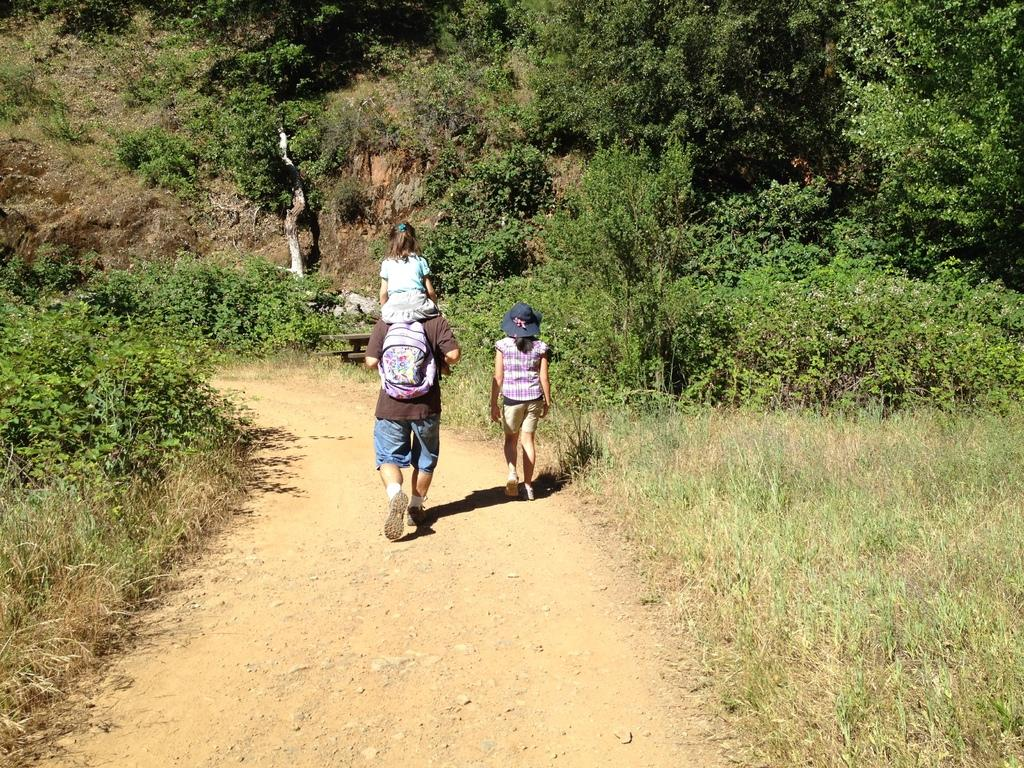What is happening in the middle of the image? There are people walking in the middle of the image. What can be seen in the background of the image? There are trees visible at the back side of the image. What type of star can be seen shining over the ocean in the image? There is no star or ocean present in the image; it features people walking and trees in the background. 